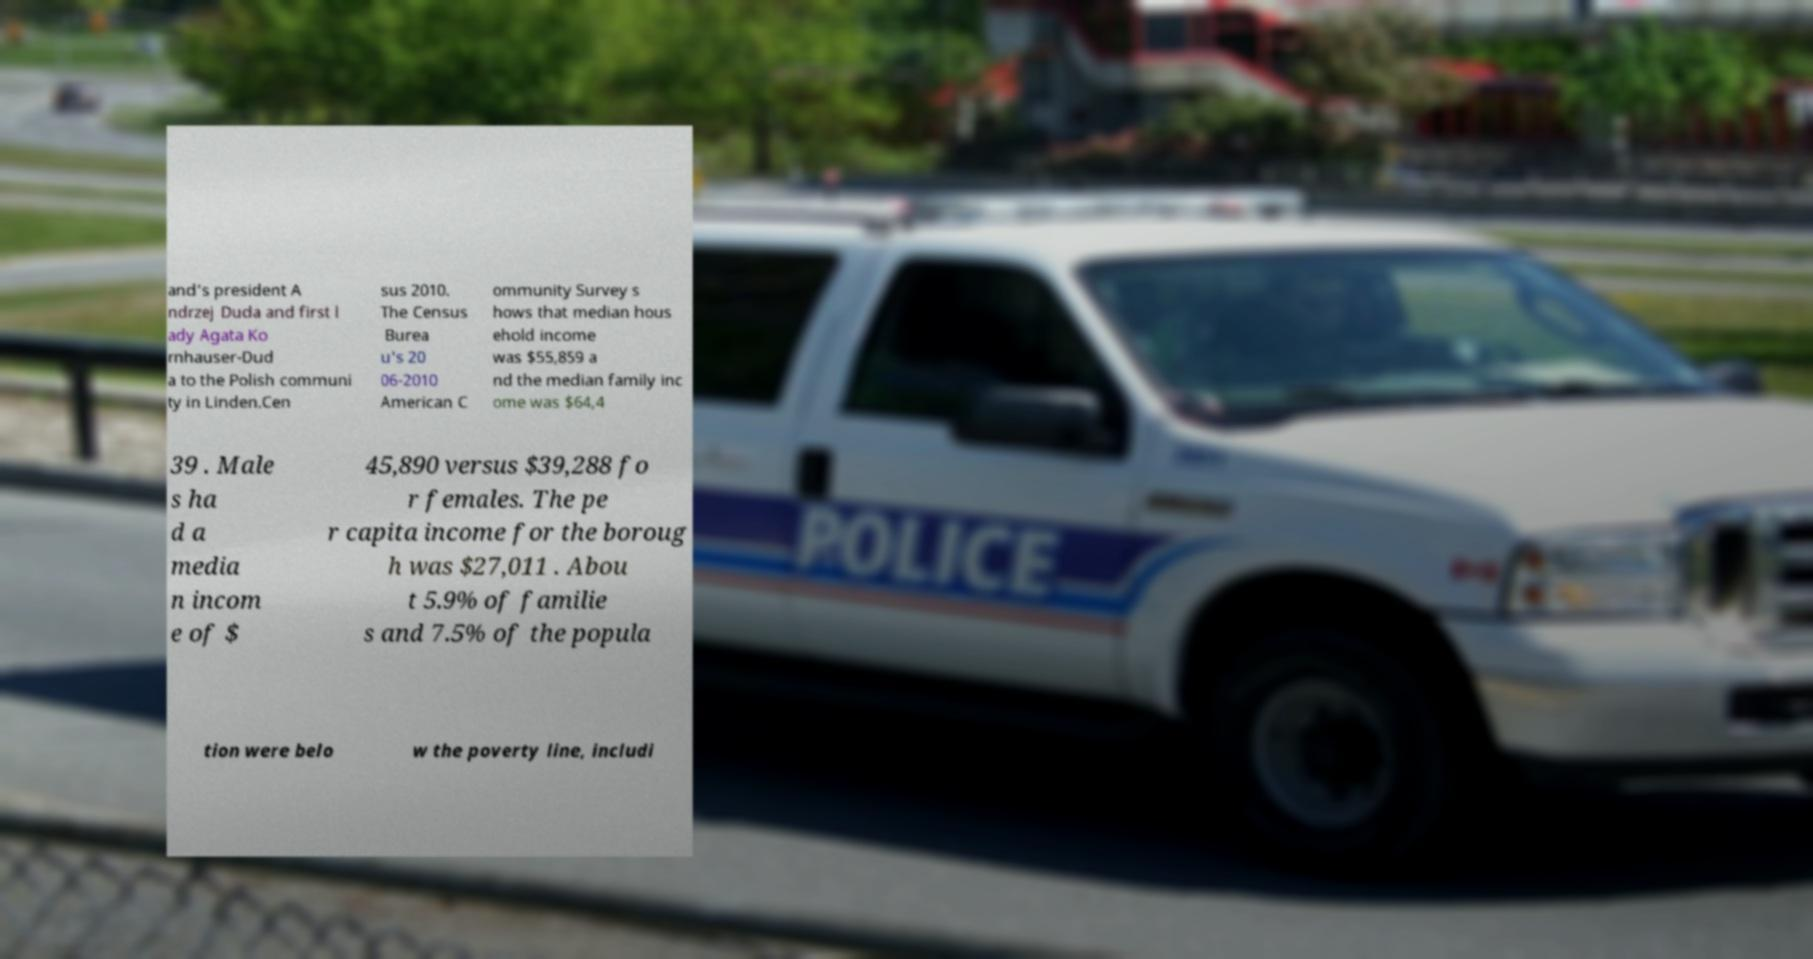There's text embedded in this image that I need extracted. Can you transcribe it verbatim? and’s president A ndrzej Duda and first l ady Agata Ko rnhauser-Dud a to the Polish communi ty in Linden.Cen sus 2010. The Census Burea u's 20 06-2010 American C ommunity Survey s hows that median hous ehold income was $55,859 a nd the median family inc ome was $64,4 39 . Male s ha d a media n incom e of $ 45,890 versus $39,288 fo r females. The pe r capita income for the boroug h was $27,011 . Abou t 5.9% of familie s and 7.5% of the popula tion were belo w the poverty line, includi 